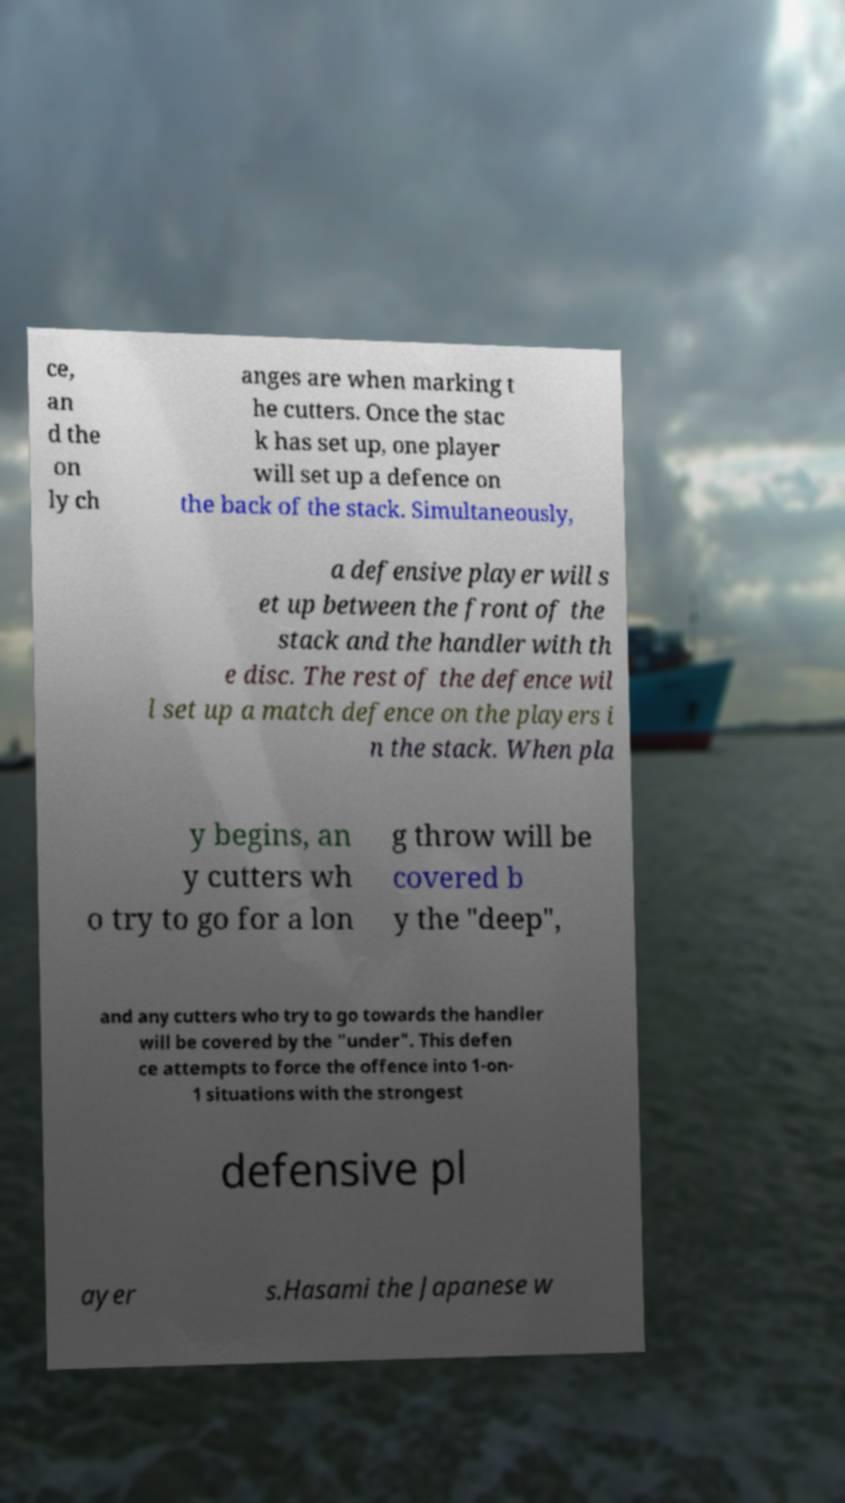Please read and relay the text visible in this image. What does it say? ce, an d the on ly ch anges are when marking t he cutters. Once the stac k has set up, one player will set up a defence on the back of the stack. Simultaneously, a defensive player will s et up between the front of the stack and the handler with th e disc. The rest of the defence wil l set up a match defence on the players i n the stack. When pla y begins, an y cutters wh o try to go for a lon g throw will be covered b y the "deep", and any cutters who try to go towards the handler will be covered by the "under". This defen ce attempts to force the offence into 1-on- 1 situations with the strongest defensive pl ayer s.Hasami the Japanese w 